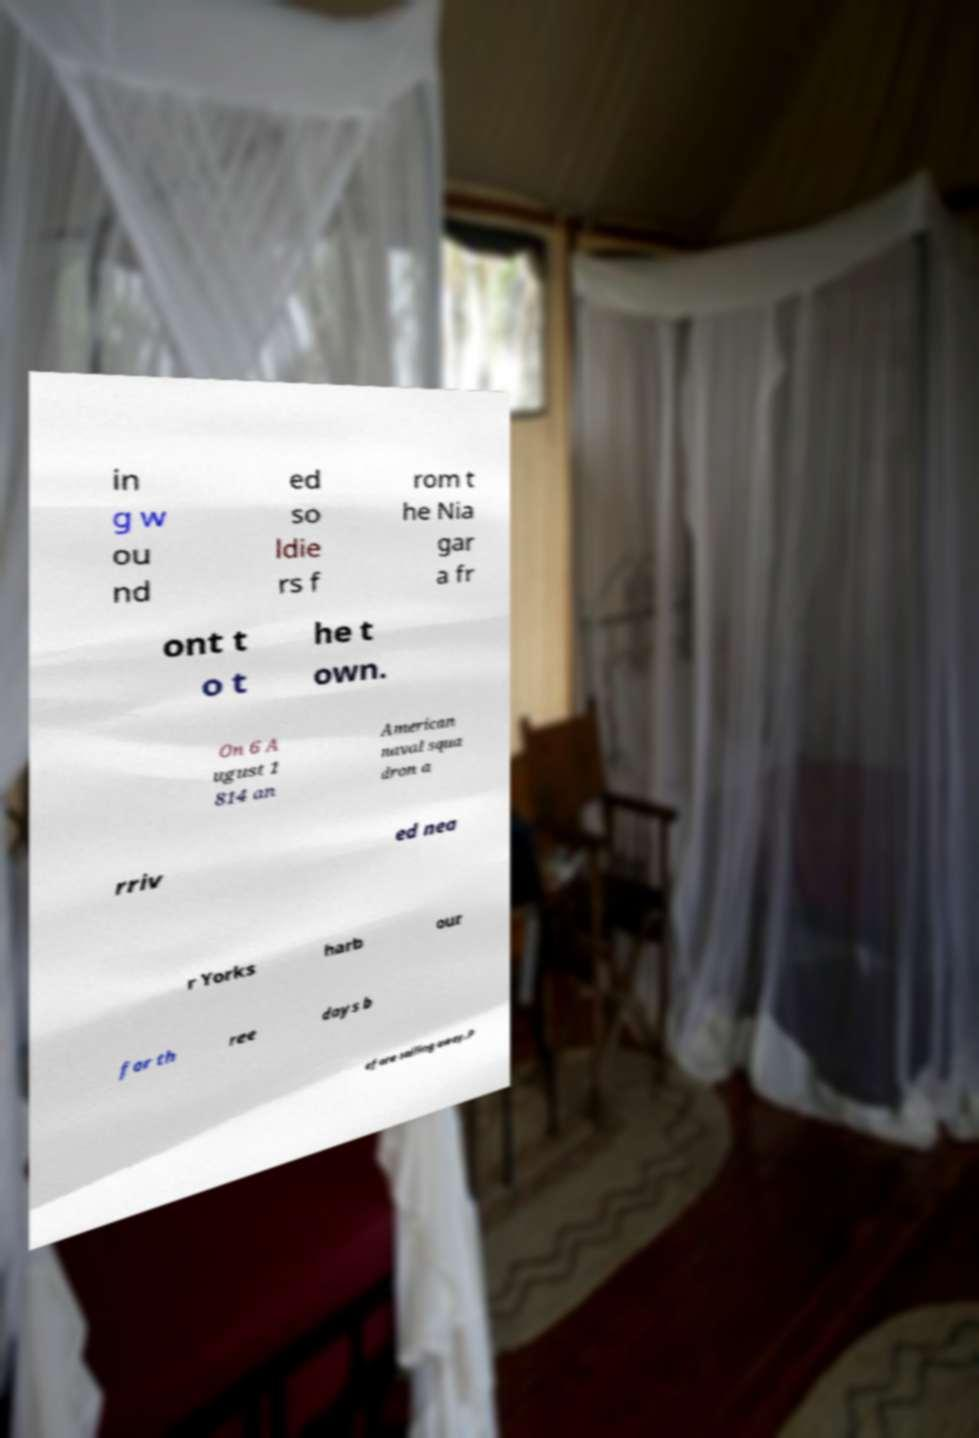Could you assist in decoding the text presented in this image and type it out clearly? in g w ou nd ed so ldie rs f rom t he Nia gar a fr ont t o t he t own. On 6 A ugust 1 814 an American naval squa dron a rriv ed nea r Yorks harb our for th ree days b efore sailing away.P 